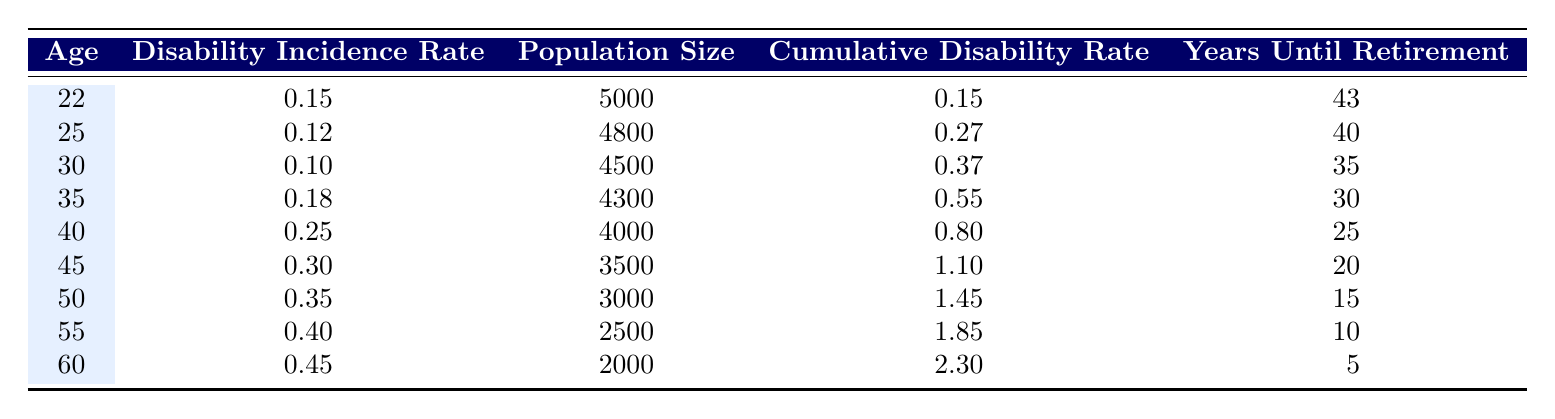What is the disability incidence rate for age 40? The table shows that the disability incidence rate for age 40 is listed directly in the second column. For age 40, the rate is 0.25.
Answer: 0.25 What is the cumulative disability rate for age 55? The cumulative disability rate can be found in the fourth column of the table. For age 55, the cumulative rate is given as 1.85.
Answer: 1.85 At what age does the disability incidence rate first exceed 0.30? To find when the incidence rate exceeds 0.30, check the incidence rates column starting from age 22. The first occurrence is at age 45 with a rate of 0.30. However, at age 50, it increases to 0.35. Therefore, age 50 is the first age with a rate exceeding 0.30.
Answer: 50 What is the average disability incidence rate for ages 30 to 60? To find the average, sum the disability incidence rates for ages 30, 35, 40, 45, 50, 55, and 60: (0.10 + 0.18 + 0.25 + 0.30 + 0.35 + 0.40 + 0.45) = 1.83. Then, divide by the number of ages (7): 1.83 / 7 = 0.2614. Rounding gives approximately 0.26.
Answer: 0.26 Is the population size for age 25 larger than that for age 30? According to the table, the population size for age 25 is 4800 and for age 30 is 4500. Since 4800 is greater than 4500, the statement is true.
Answer: Yes What is the total population size of the workforce from ages 22 to 60? To find the total population size, add together the population sizes from all relevant ages: 5000 (age 22) + 4800 (age 25) + 4500 (age 30) + 4300 (age 35) + 4000 (age 40) + 3500 (age 45) + 3000 (age 50) + 2500 (age 55) + 2000 (age 60) =  28500.
Answer: 28500 At what age does the cumulative disability rate reach 1.10? Looking at the cumulative disability rates in the table, the value of 1.10 corresponds to age 45. Therefore, the cumulative disability rate reaches 1.10 at this age.
Answer: 45 What is the difference in disability incidence rate between age 40 and age 60? The disability incidence rate for age 40 is 0.25, and for age 60, it is 0.45. The difference is calculated as 0.45 - 0.25 = 0.20.
Answer: 0.20 